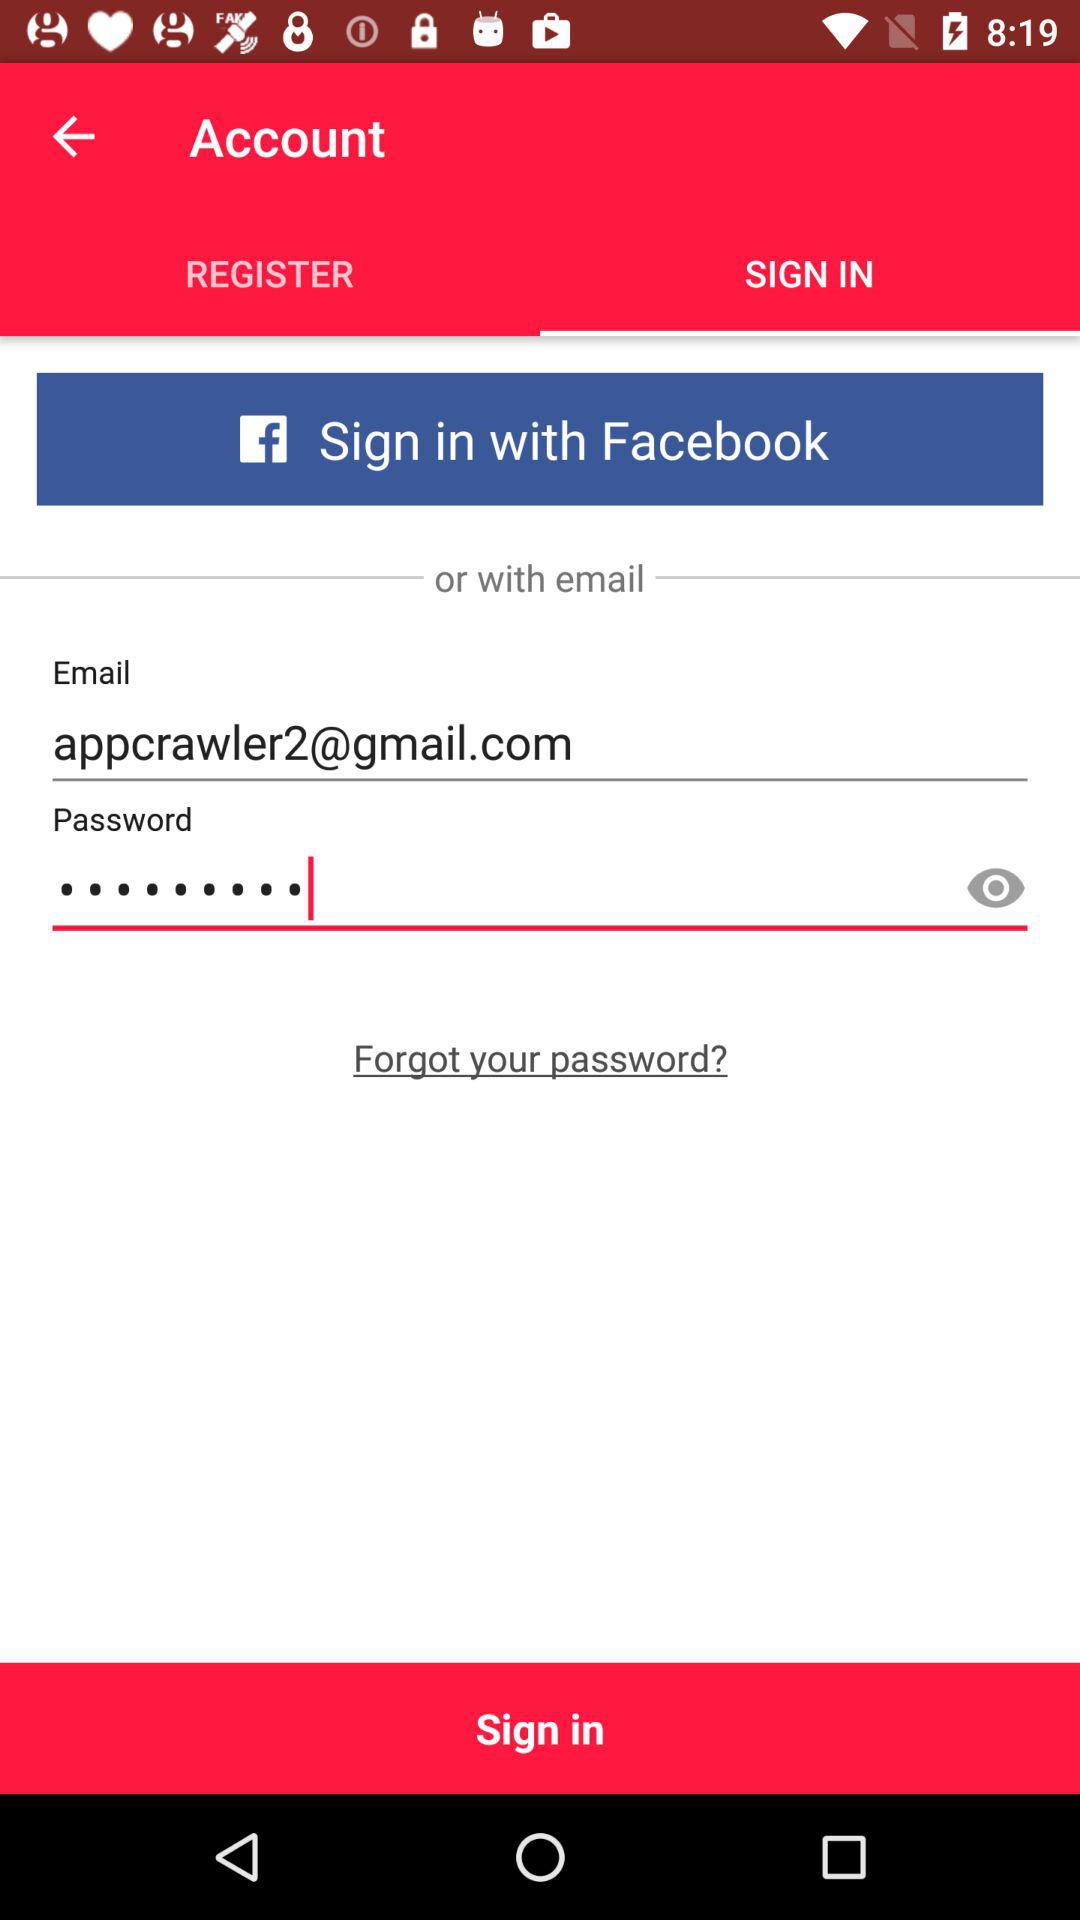Which tab is selected? The selected tab is "SIGN IN". 